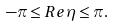<formula> <loc_0><loc_0><loc_500><loc_500>- \pi \leq R e \eta \leq \pi .</formula> 